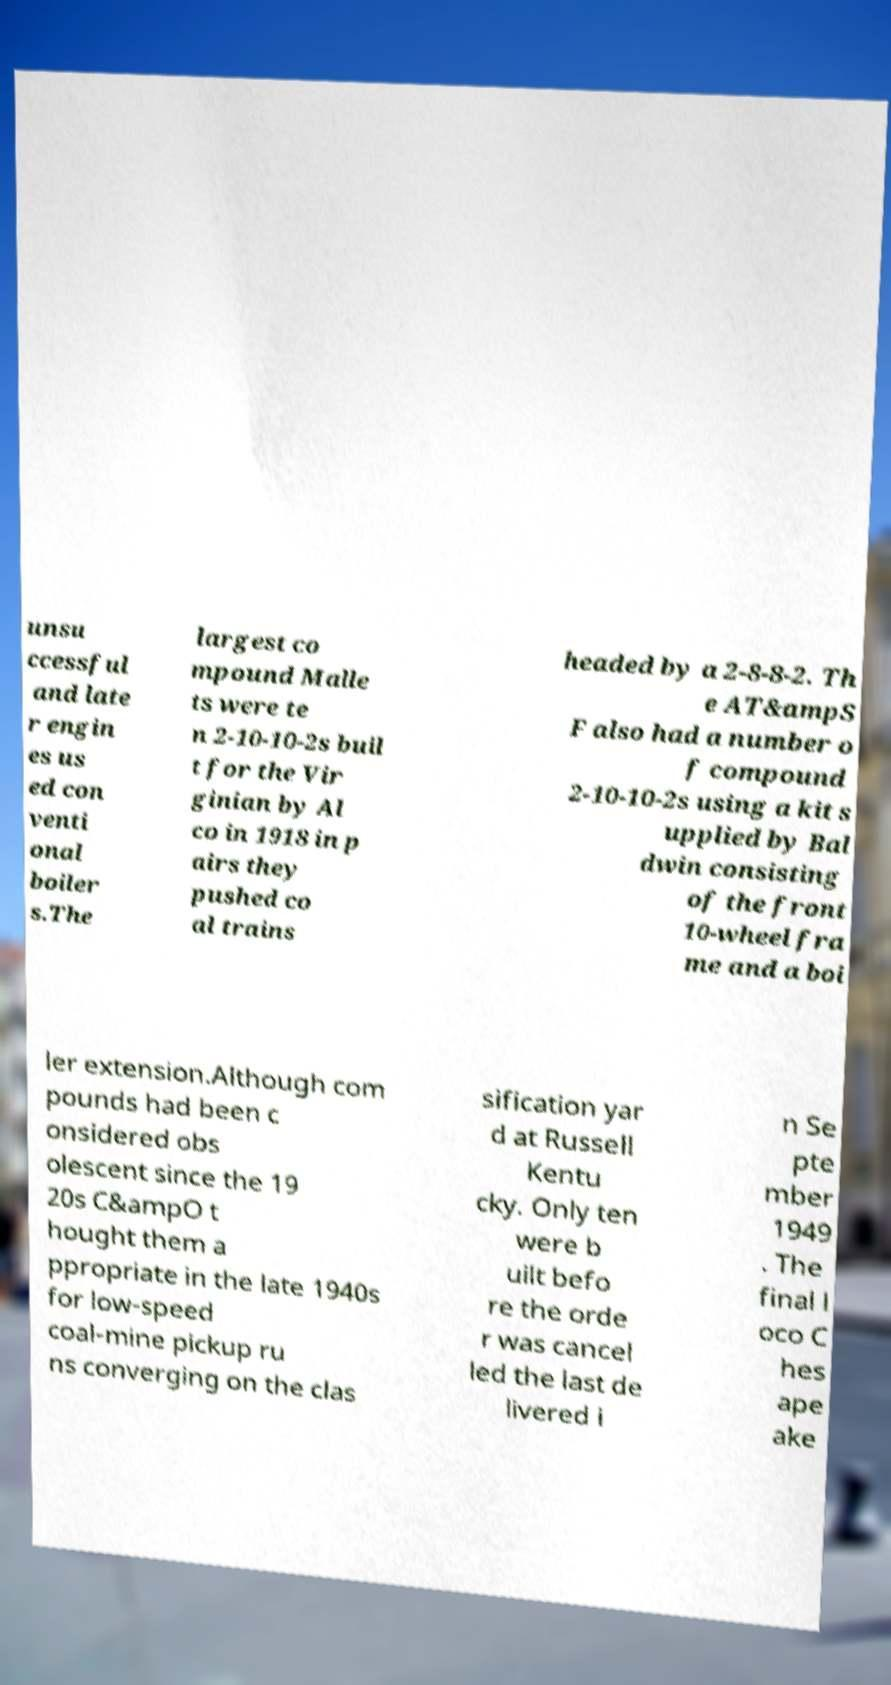Could you assist in decoding the text presented in this image and type it out clearly? unsu ccessful and late r engin es us ed con venti onal boiler s.The largest co mpound Malle ts were te n 2-10-10-2s buil t for the Vir ginian by Al co in 1918 in p airs they pushed co al trains headed by a 2-8-8-2. Th e AT&ampS F also had a number o f compound 2-10-10-2s using a kit s upplied by Bal dwin consisting of the front 10-wheel fra me and a boi ler extension.Although com pounds had been c onsidered obs olescent since the 19 20s C&ampO t hought them a ppropriate in the late 1940s for low-speed coal-mine pickup ru ns converging on the clas sification yar d at Russell Kentu cky. Only ten were b uilt befo re the orde r was cancel led the last de livered i n Se pte mber 1949 . The final l oco C hes ape ake 